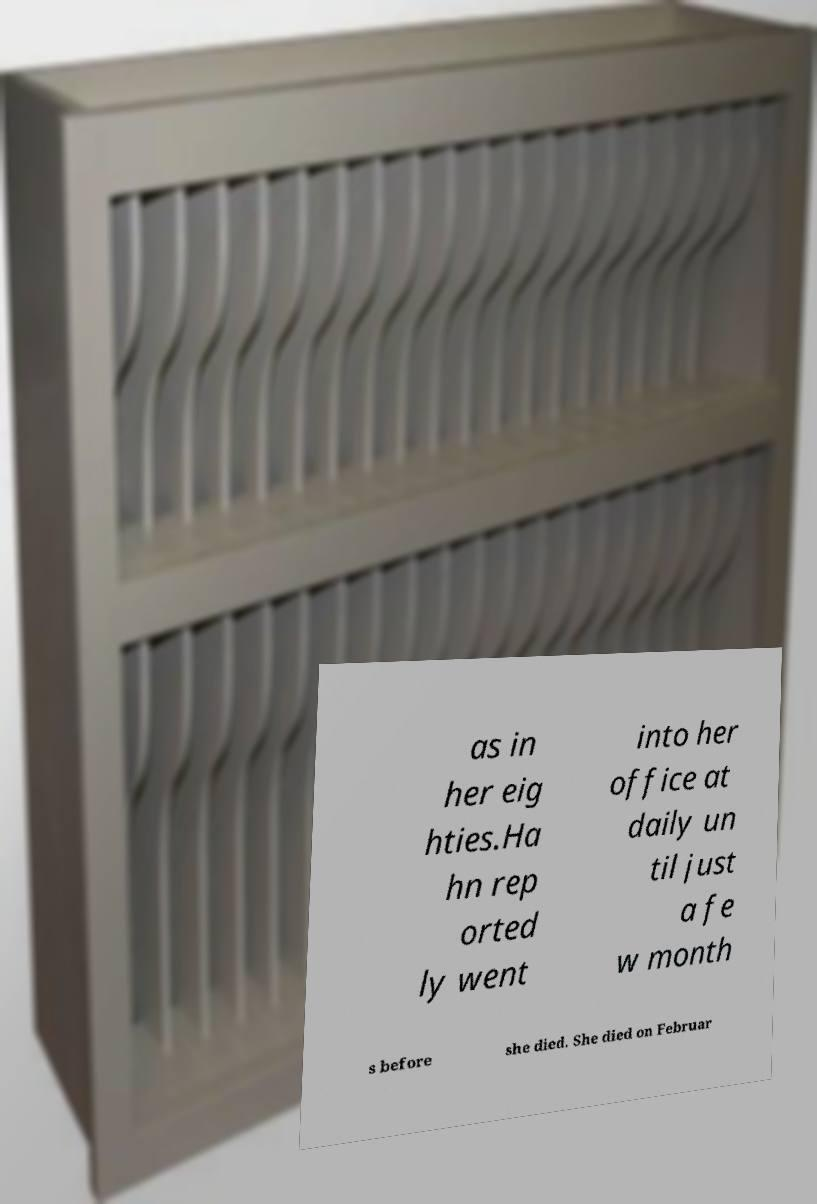Could you assist in decoding the text presented in this image and type it out clearly? as in her eig hties.Ha hn rep orted ly went into her office at daily un til just a fe w month s before she died. She died on Februar 